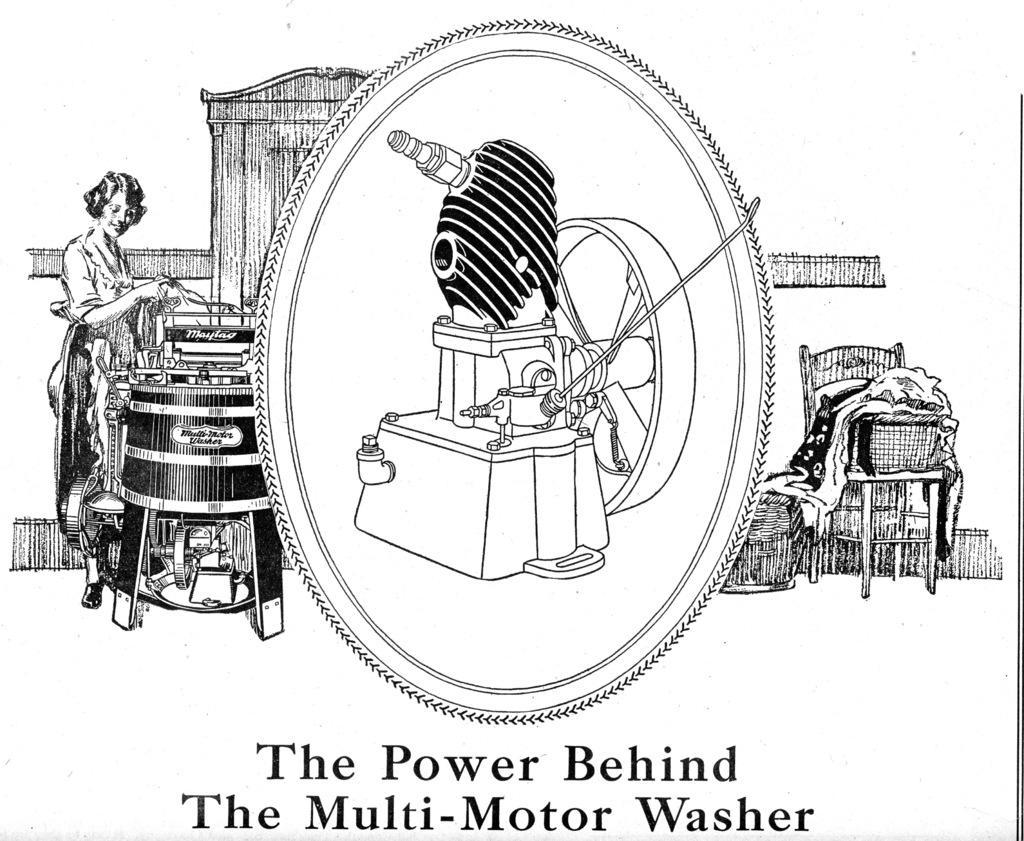Please provide a concise description of this image. This picture consists of images of person and a baby and an equipment and a chair, clothes and a text visible at the bottom 